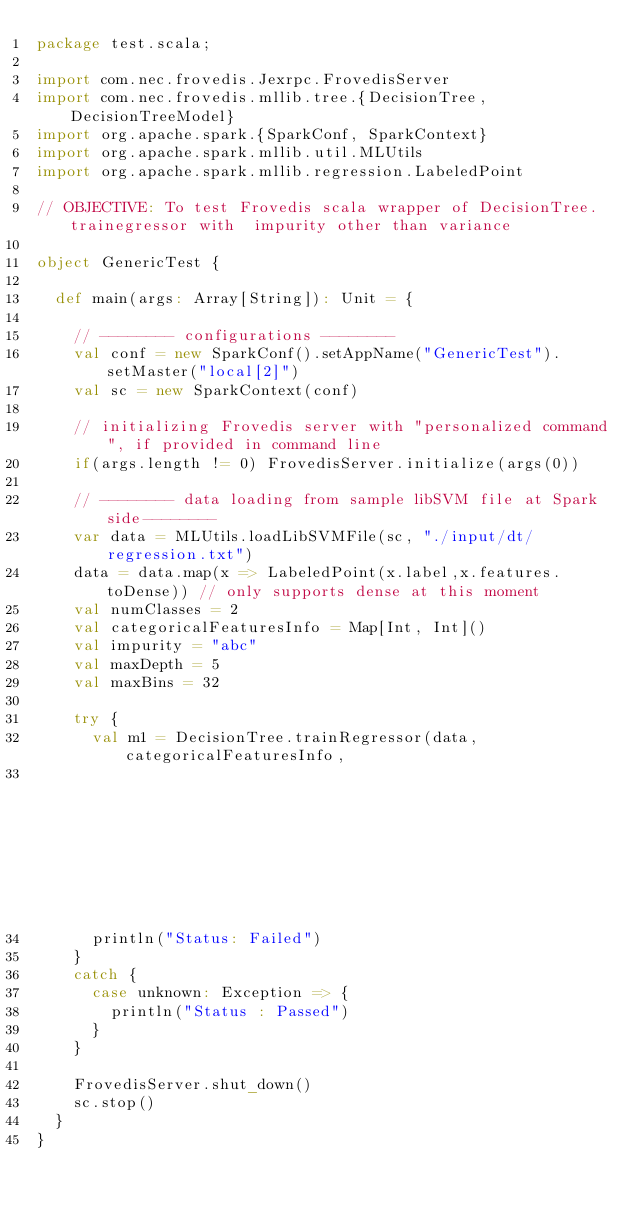<code> <loc_0><loc_0><loc_500><loc_500><_Scala_>package test.scala;

import com.nec.frovedis.Jexrpc.FrovedisServer
import com.nec.frovedis.mllib.tree.{DecisionTree, DecisionTreeModel}
import org.apache.spark.{SparkConf, SparkContext}
import org.apache.spark.mllib.util.MLUtils
import org.apache.spark.mllib.regression.LabeledPoint

// OBJECTIVE: To test Frovedis scala wrapper of DecisionTree.trainegressor with  impurity other than variance

object GenericTest {

  def main(args: Array[String]): Unit = {

    // -------- configurations --------
    val conf = new SparkConf().setAppName("GenericTest").setMaster("local[2]")
    val sc = new SparkContext(conf)

    // initializing Frovedis server with "personalized command", if provided in command line
    if(args.length != 0) FrovedisServer.initialize(args(0))

    // -------- data loading from sample libSVM file at Spark side--------
    var data = MLUtils.loadLibSVMFile(sc, "./input/dt/regression.txt")
    data = data.map(x => LabeledPoint(x.label,x.features.toDense)) // only supports dense at this moment
    val numClasses = 2
    val categoricalFeaturesInfo = Map[Int, Int]()
    val impurity = "abc" 
    val maxDepth = 5
    val maxBins = 32

    try {
      val m1 = DecisionTree.trainRegressor(data, categoricalFeaturesInfo,
                                                                     impurity, maxDepth, maxBins)
      println("Status: Failed") 
    }
    catch {
      case unknown: Exception => {
        println("Status : Passed")
      }
    }

    FrovedisServer.shut_down()
    sc.stop()
  }
}



</code> 